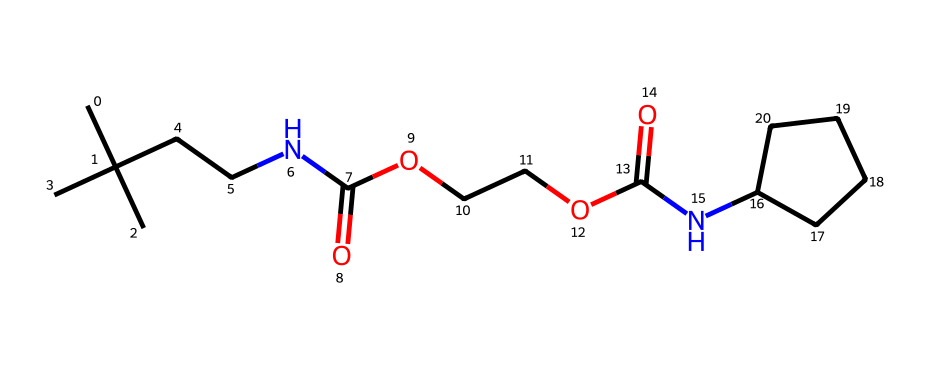What type of chemical is represented by this SMILES? The SMILES notation indicates that the compound contains amide (from NC(=O)) and ether (from O). This suggests that the chemical is a type of polyurethane used in insulation applications, which are often made with ester and amide linkages.
Answer: polyurethane How many nitrogen atoms are present in the structure? By examining the SMILES, we can identify two occurrences of nitrogen (N), confirming the presence of two nitrogen atoms.
Answer: 2 What functional groups are present in this chemical? The SMILES shows the presence of amide (C(=O)N), ether (C-O-C), and carboxylic acid (C(=O)O) functional groups, which indicates multiple functional features.
Answer: amide, ether, carboxylic acid What is the total number of carbon atoms in the structure? Counting each carbon (C) represented in the SMILES string, there are a total of 11 carbon atoms.
Answer: 11 Which part of the chemical is responsible for its insulation properties? The long hydrocarbon chains and the presence of the ether and amide bonds contribute to the low thermal conductivity, allowing the material to act as an effective thermal insulator.
Answer: hydrocarbon chains, ether, amide bonds How many oxygen atoms are in the structure? The SMILES notation contains 4 oxygen atoms (O) based on their appearance in the functional groups.
Answer: 4 